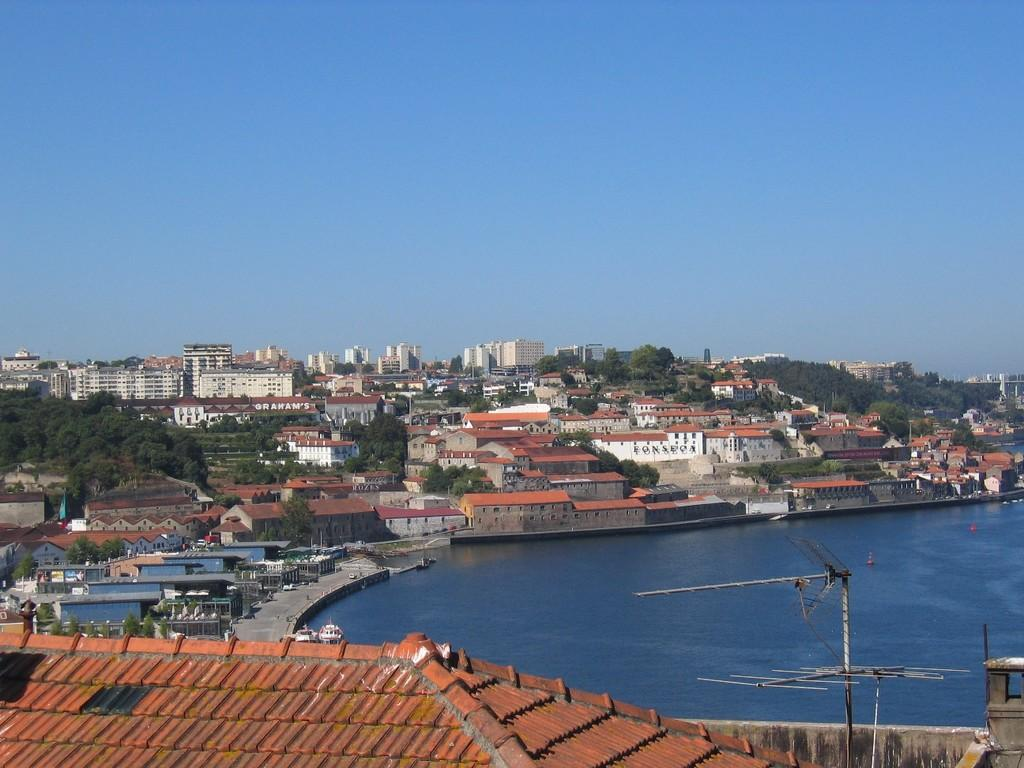What type of structures can be seen in the image? There are buildings in the image. What feature can be observed on the buildings? There are windows visible in the image. What type of vegetation is present in the image? There are trees in the image. What are the poles used for in the image? The purpose of the poles is not specified, but they are visible in the image. What is floating on the water surface in the image? There are boats on the water surface in the image. What part of the natural environment is visible in the image? The sky is visible in the image. Reasoning: Let' Let's think step by step in order to produce the conversation. We start by identifying the main subjects and objects in the image based on the provided facts. We then formulate questions that focus on the location and characteristics of these subjects and objects, ensuring that each question can be answered definitively with the information given. We avoid yes/no questions and ensure that the language is simple and clear. Absurd Question/Answer: Where is the tray located in the image? There is no tray present in the image. What type of waste can be seen in the image? There is no waste visible in the image. Are there any police officers visible in the image? There are no police officers present in the image. 